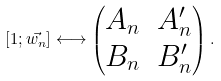Convert formula to latex. <formula><loc_0><loc_0><loc_500><loc_500>[ 1 ; \vec { w _ { n } } ] \longleftrightarrow \left ( \begin{matrix} A _ { n } & A _ { n } ^ { \prime } \\ B _ { n } & B _ { n } ^ { \prime } \end{matrix} \right ) .</formula> 